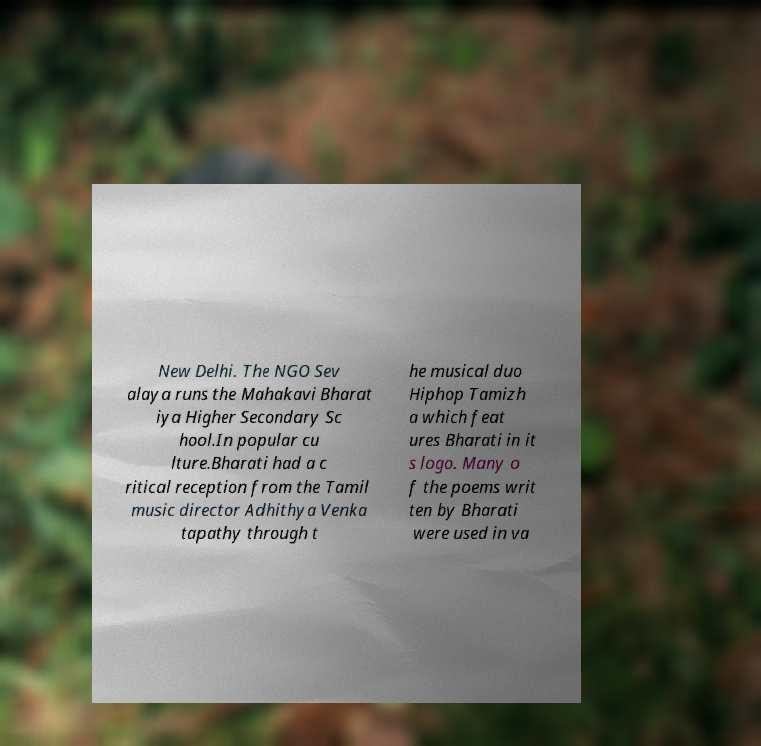Can you accurately transcribe the text from the provided image for me? New Delhi. The NGO Sev alaya runs the Mahakavi Bharat iya Higher Secondary Sc hool.In popular cu lture.Bharati had a c ritical reception from the Tamil music director Adhithya Venka tapathy through t he musical duo Hiphop Tamizh a which feat ures Bharati in it s logo. Many o f the poems writ ten by Bharati were used in va 